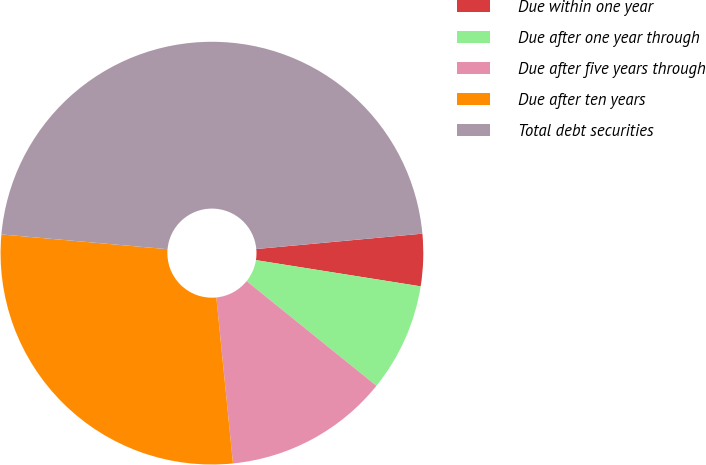Convert chart. <chart><loc_0><loc_0><loc_500><loc_500><pie_chart><fcel>Due within one year<fcel>Due after one year through<fcel>Due after five years through<fcel>Due after ten years<fcel>Total debt securities<nl><fcel>3.98%<fcel>8.29%<fcel>12.61%<fcel>28.0%<fcel>47.12%<nl></chart> 